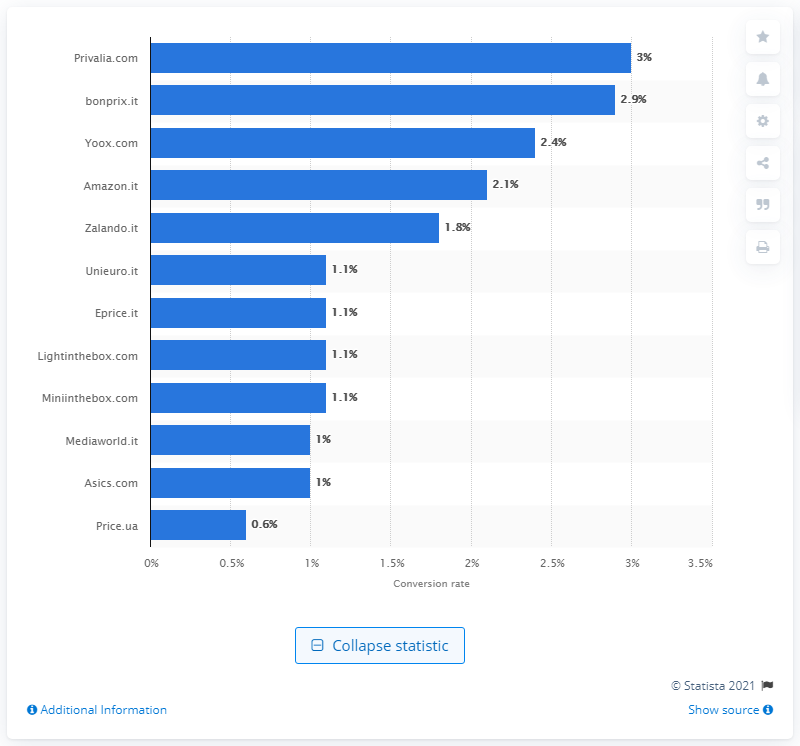Identify some key points in this picture. In 2017, Privalia.com had the highest conversion rate among websites in Italy. Bonprix.it had a conversion rate of 2.9% in 2017. 